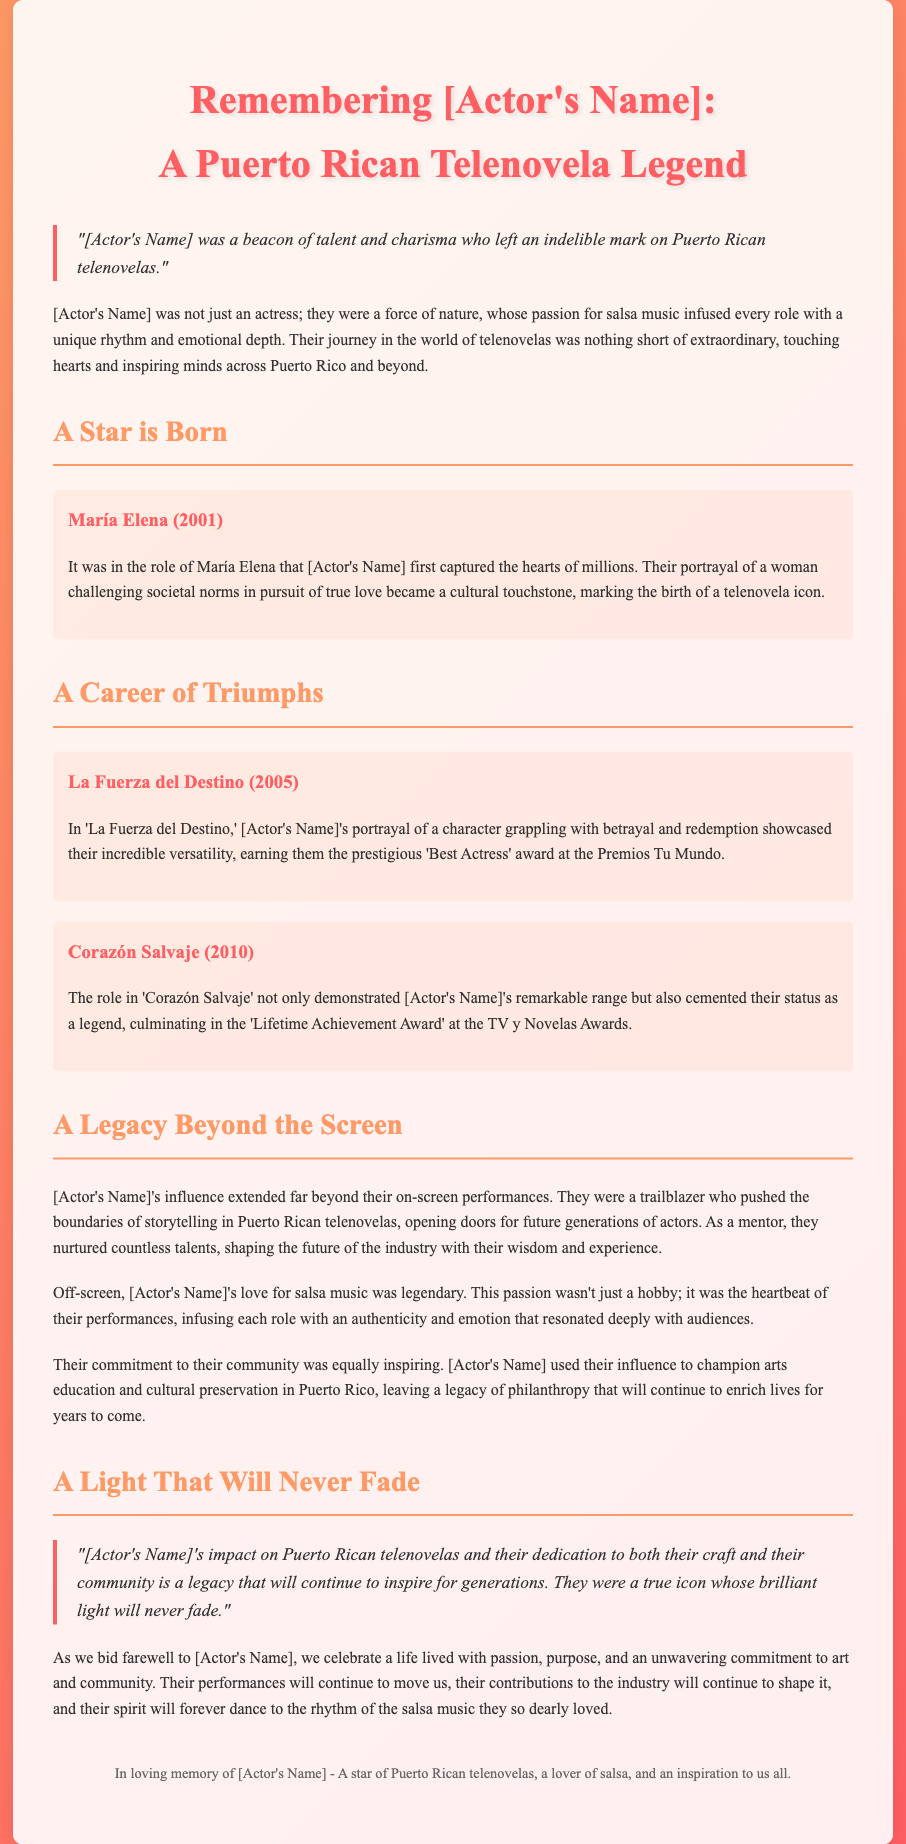What role did [Actor's Name] first capture hearts in? The document states that [Actor's Name] first captured the hearts of millions in the role of María Elena.
Answer: María Elena In which year did [Actor's Name] portray María Elena? The document specifies the year of the role of María Elena as 2001.
Answer: 2001 What award did [Actor's Name] win for 'La Fuerza del Destino'? The text indicates that [Actor's Name] earned the prestigious 'Best Actress' award at the Premios Tu Mundo for this role.
Answer: Best Actress Which significant award did [Actor's Name] receive in 2010 for their role in 'Corazón Salvaje'? It is mentioned that [Actor's Name] received the 'Lifetime Achievement Award' at the TV y Novelas Awards for this role.
Answer: Lifetime Achievement Award What was a notable extracurricular passion of [Actor's Name]? The document highlights [Actor's Name]'s love for salsa music as a legendary aspect of their life.
Answer: Salsa music How did [Actor's Name]'s influence extend beyond acting? It mentions that [Actor's Name] was a mentor shaping the future of the industry.
Answer: Mentor What did [Actor's Name] champion through their influence? The document states that [Actor's Name] used their influence to champion arts education and cultural preservation in Puerto Rico.
Answer: Arts education and cultural preservation What is described as the heartbeat of [Actor's Name]'s performances? The document describes [Actor's Name]'s passion for salsa music as the heartbeat of their performances.
Answer: Salsa music What phrase is used to express [Actor's Name]'s lasting impact? The document quotes that [Actor's Name]'s impact is a legacy that will continue to inspire for generations.
Answer: Continue to inspire for generations 